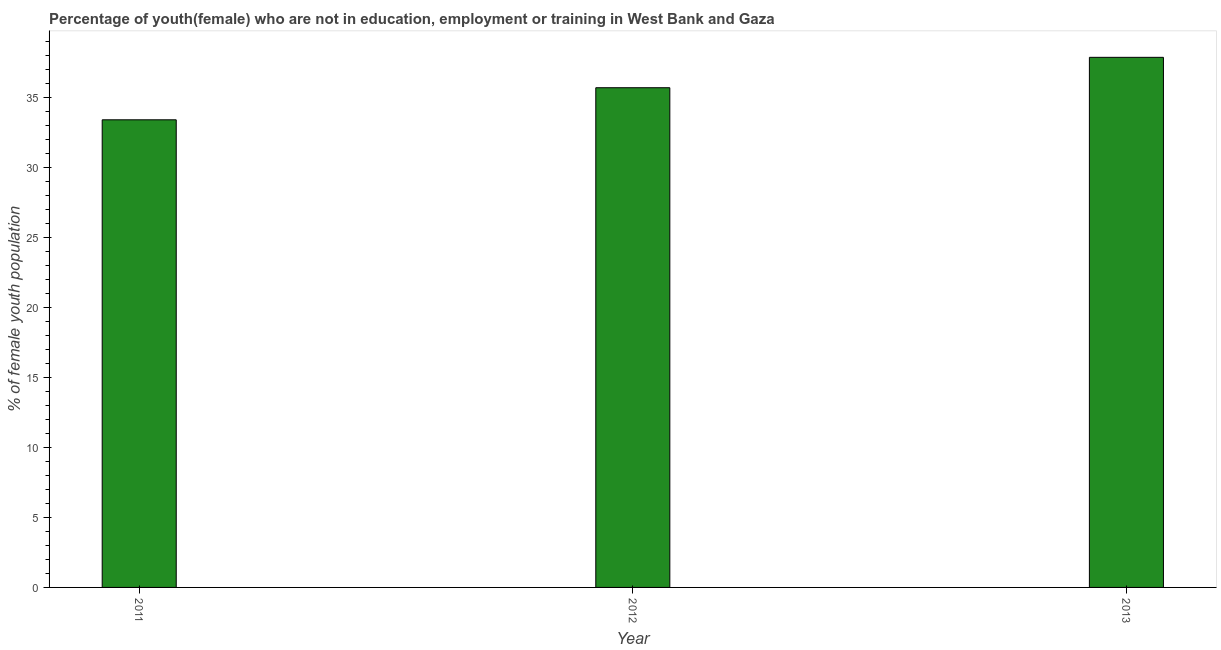Does the graph contain grids?
Ensure brevity in your answer.  No. What is the title of the graph?
Offer a terse response. Percentage of youth(female) who are not in education, employment or training in West Bank and Gaza. What is the label or title of the Y-axis?
Keep it short and to the point. % of female youth population. What is the unemployed female youth population in 2013?
Keep it short and to the point. 37.84. Across all years, what is the maximum unemployed female youth population?
Give a very brief answer. 37.84. Across all years, what is the minimum unemployed female youth population?
Make the answer very short. 33.38. In which year was the unemployed female youth population maximum?
Your answer should be compact. 2013. In which year was the unemployed female youth population minimum?
Your response must be concise. 2011. What is the sum of the unemployed female youth population?
Keep it short and to the point. 106.89. What is the difference between the unemployed female youth population in 2011 and 2012?
Offer a very short reply. -2.29. What is the average unemployed female youth population per year?
Your response must be concise. 35.63. What is the median unemployed female youth population?
Give a very brief answer. 35.67. Do a majority of the years between 2011 and 2013 (inclusive) have unemployed female youth population greater than 5 %?
Offer a terse response. Yes. What is the ratio of the unemployed female youth population in 2012 to that in 2013?
Offer a terse response. 0.94. Is the difference between the unemployed female youth population in 2011 and 2013 greater than the difference between any two years?
Keep it short and to the point. Yes. What is the difference between the highest and the second highest unemployed female youth population?
Ensure brevity in your answer.  2.17. What is the difference between the highest and the lowest unemployed female youth population?
Offer a very short reply. 4.46. Are all the bars in the graph horizontal?
Your response must be concise. No. Are the values on the major ticks of Y-axis written in scientific E-notation?
Keep it short and to the point. No. What is the % of female youth population of 2011?
Ensure brevity in your answer.  33.38. What is the % of female youth population of 2012?
Your response must be concise. 35.67. What is the % of female youth population in 2013?
Your response must be concise. 37.84. What is the difference between the % of female youth population in 2011 and 2012?
Your answer should be compact. -2.29. What is the difference between the % of female youth population in 2011 and 2013?
Your answer should be compact. -4.46. What is the difference between the % of female youth population in 2012 and 2013?
Your answer should be very brief. -2.17. What is the ratio of the % of female youth population in 2011 to that in 2012?
Provide a short and direct response. 0.94. What is the ratio of the % of female youth population in 2011 to that in 2013?
Your answer should be very brief. 0.88. What is the ratio of the % of female youth population in 2012 to that in 2013?
Your answer should be very brief. 0.94. 